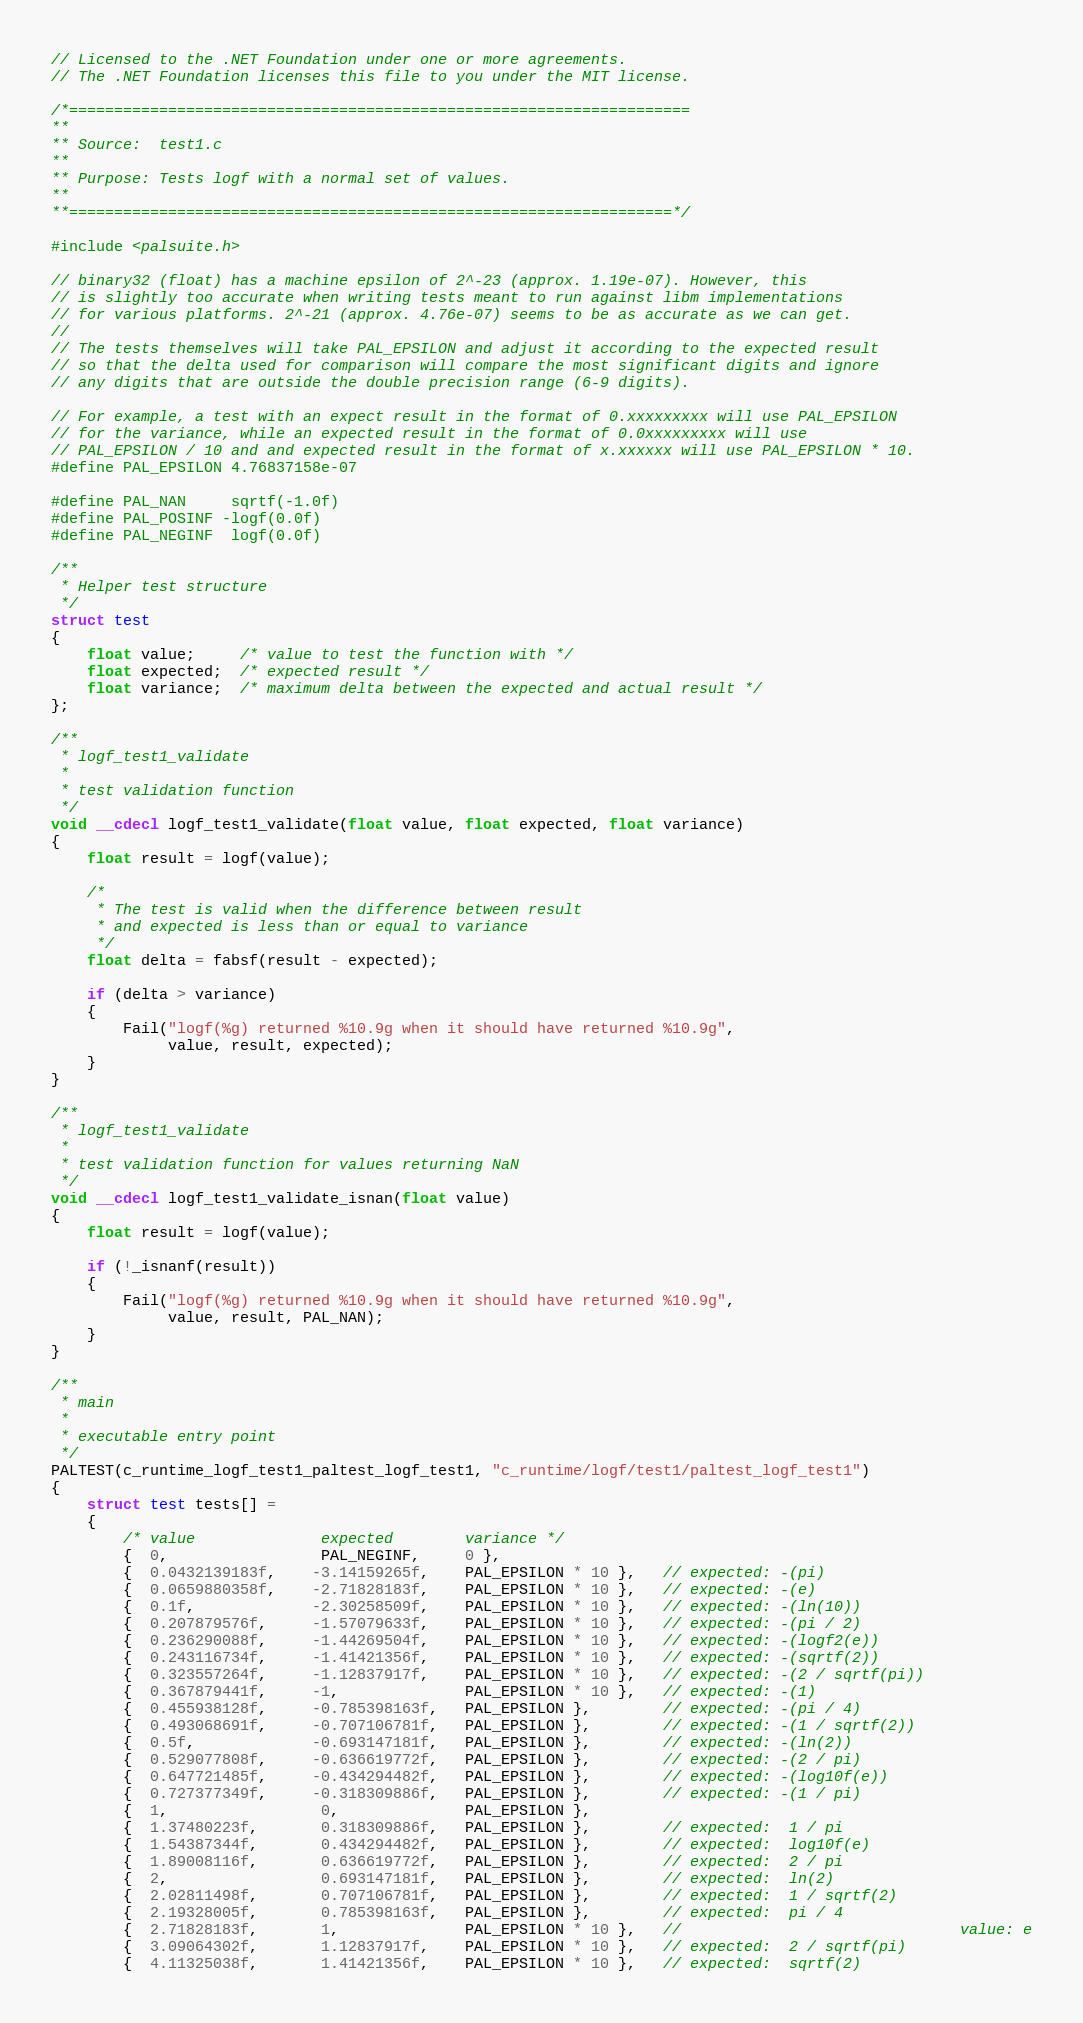Convert code to text. <code><loc_0><loc_0><loc_500><loc_500><_C++_>// Licensed to the .NET Foundation under one or more agreements.
// The .NET Foundation licenses this file to you under the MIT license.

/*=====================================================================
**
** Source:  test1.c
**
** Purpose: Tests logf with a normal set of values.
**
**===================================================================*/

#include <palsuite.h>

// binary32 (float) has a machine epsilon of 2^-23 (approx. 1.19e-07). However, this 
// is slightly too accurate when writing tests meant to run against libm implementations
// for various platforms. 2^-21 (approx. 4.76e-07) seems to be as accurate as we can get.
//
// The tests themselves will take PAL_EPSILON and adjust it according to the expected result
// so that the delta used for comparison will compare the most significant digits and ignore
// any digits that are outside the double precision range (6-9 digits).

// For example, a test with an expect result in the format of 0.xxxxxxxxx will use PAL_EPSILON
// for the variance, while an expected result in the format of 0.0xxxxxxxxx will use
// PAL_EPSILON / 10 and and expected result in the format of x.xxxxxx will use PAL_EPSILON * 10.
#define PAL_EPSILON 4.76837158e-07

#define PAL_NAN     sqrtf(-1.0f)
#define PAL_POSINF -logf(0.0f)
#define PAL_NEGINF  logf(0.0f)

/**
 * Helper test structure
 */
struct test
{
    float value;     /* value to test the function with */
    float expected;  /* expected result */
    float variance;  /* maximum delta between the expected and actual result */
};

/**
 * logf_test1_validate
 *
 * test validation function
 */
void __cdecl logf_test1_validate(float value, float expected, float variance)
{
    float result = logf(value);

    /*
     * The test is valid when the difference between result
     * and expected is less than or equal to variance
     */
    float delta = fabsf(result - expected);

    if (delta > variance)
    {
        Fail("logf(%g) returned %10.9g when it should have returned %10.9g",
             value, result, expected);
    }
}

/**
 * logf_test1_validate
 *
 * test validation function for values returning NaN
 */
void __cdecl logf_test1_validate_isnan(float value)
{
    float result = logf(value);

    if (!_isnanf(result))
    {
        Fail("logf(%g) returned %10.9g when it should have returned %10.9g",
             value, result, PAL_NAN);
    }
}

/**
 * main
 * 
 * executable entry point
 */
PALTEST(c_runtime_logf_test1_paltest_logf_test1, "c_runtime/logf/test1/paltest_logf_test1")
{
    struct test tests[] = 
    {
        /* value              expected        variance */
        {  0,                 PAL_NEGINF,     0 },
        {  0.0432139183f,    -3.14159265f,    PAL_EPSILON * 10 },   // expected: -(pi)
        {  0.0659880358f,    -2.71828183f,    PAL_EPSILON * 10 },   // expected: -(e)
        {  0.1f,             -2.30258509f,    PAL_EPSILON * 10 },   // expected: -(ln(10))
        {  0.207879576f,     -1.57079633f,    PAL_EPSILON * 10 },   // expected: -(pi / 2)
        {  0.236290088f,     -1.44269504f,    PAL_EPSILON * 10 },   // expected: -(logf2(e))
        {  0.243116734f,     -1.41421356f,    PAL_EPSILON * 10 },   // expected: -(sqrtf(2))
        {  0.323557264f,     -1.12837917f,    PAL_EPSILON * 10 },   // expected: -(2 / sqrtf(pi))
        {  0.367879441f,     -1,              PAL_EPSILON * 10 },   // expected: -(1)
        {  0.455938128f,     -0.785398163f,   PAL_EPSILON },        // expected: -(pi / 4)
        {  0.493068691f,     -0.707106781f,   PAL_EPSILON },        // expected: -(1 / sqrtf(2))
        {  0.5f,             -0.693147181f,   PAL_EPSILON },        // expected: -(ln(2))
        {  0.529077808f,     -0.636619772f,   PAL_EPSILON },        // expected: -(2 / pi)
        {  0.647721485f,     -0.434294482f,   PAL_EPSILON },        // expected: -(log10f(e))
        {  0.727377349f,     -0.318309886f,   PAL_EPSILON },        // expected: -(1 / pi)
        {  1,                 0,              PAL_EPSILON },
        {  1.37480223f,       0.318309886f,   PAL_EPSILON },        // expected:  1 / pi
        {  1.54387344f,       0.434294482f,   PAL_EPSILON },        // expected:  log10f(e)
        {  1.89008116f,       0.636619772f,   PAL_EPSILON },        // expected:  2 / pi
        {  2,                 0.693147181f,   PAL_EPSILON },        // expected:  ln(2)
        {  2.02811498f,       0.707106781f,   PAL_EPSILON },        // expected:  1 / sqrtf(2)
        {  2.19328005f,       0.785398163f,   PAL_EPSILON },        // expected:  pi / 4
        {  2.71828183f,       1,              PAL_EPSILON * 10 },   //                               value: e
        {  3.09064302f,       1.12837917f,    PAL_EPSILON * 10 },   // expected:  2 / sqrtf(pi)
        {  4.11325038f,       1.41421356f,    PAL_EPSILON * 10 },   // expected:  sqrtf(2)</code> 